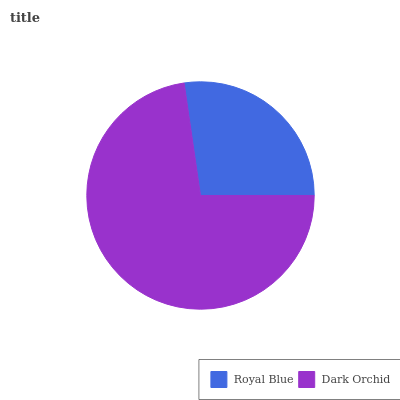Is Royal Blue the minimum?
Answer yes or no. Yes. Is Dark Orchid the maximum?
Answer yes or no. Yes. Is Dark Orchid the minimum?
Answer yes or no. No. Is Dark Orchid greater than Royal Blue?
Answer yes or no. Yes. Is Royal Blue less than Dark Orchid?
Answer yes or no. Yes. Is Royal Blue greater than Dark Orchid?
Answer yes or no. No. Is Dark Orchid less than Royal Blue?
Answer yes or no. No. Is Dark Orchid the high median?
Answer yes or no. Yes. Is Royal Blue the low median?
Answer yes or no. Yes. Is Royal Blue the high median?
Answer yes or no. No. Is Dark Orchid the low median?
Answer yes or no. No. 